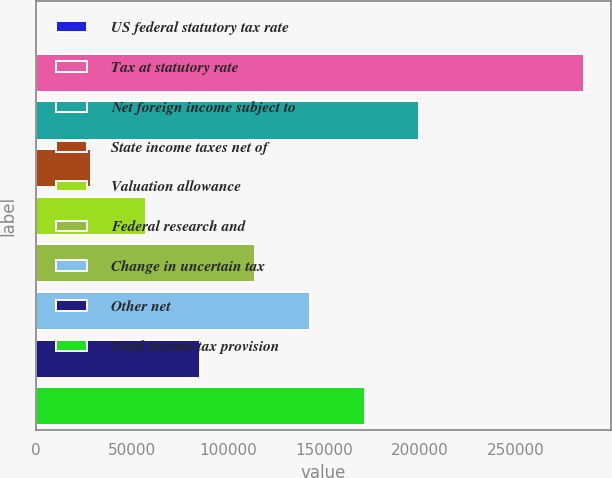Convert chart. <chart><loc_0><loc_0><loc_500><loc_500><bar_chart><fcel>US federal statutory tax rate<fcel>Tax at statutory rate<fcel>Net foreign income subject to<fcel>State income taxes net of<fcel>Valuation allowance<fcel>Federal research and<fcel>Change in uncertain tax<fcel>Other net<fcel>Total income tax provision<nl><fcel>35<fcel>285363<fcel>199765<fcel>28567.8<fcel>57100.6<fcel>114166<fcel>142699<fcel>85633.4<fcel>171232<nl></chart> 